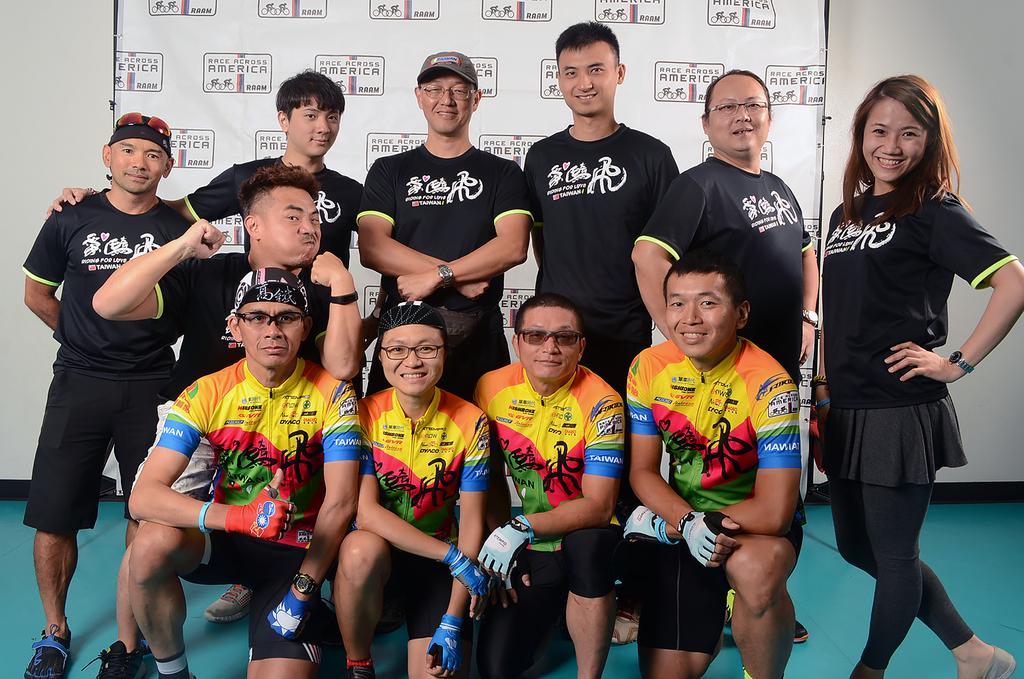What can be seen in the image? There is a group of people in the image. What are some of the people in the group wearing? Some people in the group are wearing black color T-shirts. Are there any accessories visible on the people in the group? Yes, some people in the group are wearing spectacles. What is visible in the background of the image? There is a hoarding in the background of the image. What type of copper material is present in the image? There is no copper material present in the image. What committee is responsible for organizing the event in the image? There is no event or committee mentioned in the image. 